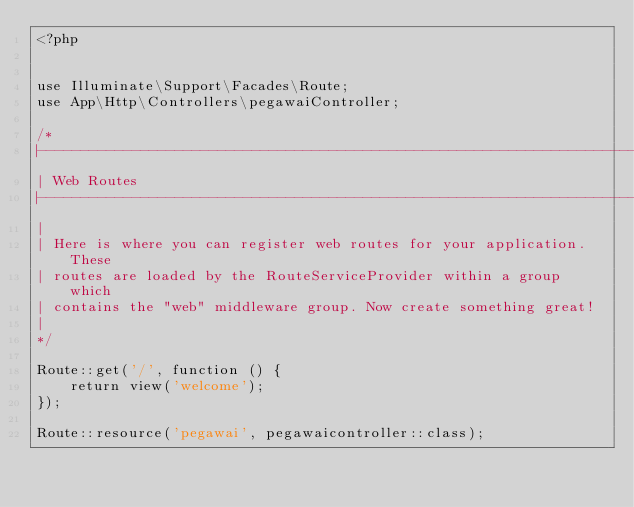Convert code to text. <code><loc_0><loc_0><loc_500><loc_500><_PHP_><?php


use Illuminate\Support\Facades\Route;
use App\Http\Controllers\pegawaiController;

/*
|--------------------------------------------------------------------------
| Web Routes
|--------------------------------------------------------------------------
|
| Here is where you can register web routes for your application. These
| routes are loaded by the RouteServiceProvider within a group which
| contains the "web" middleware group. Now create something great!
|
*/

Route::get('/', function () {
    return view('welcome');
});

Route::resource('pegawai', pegawaicontroller::class);
</code> 